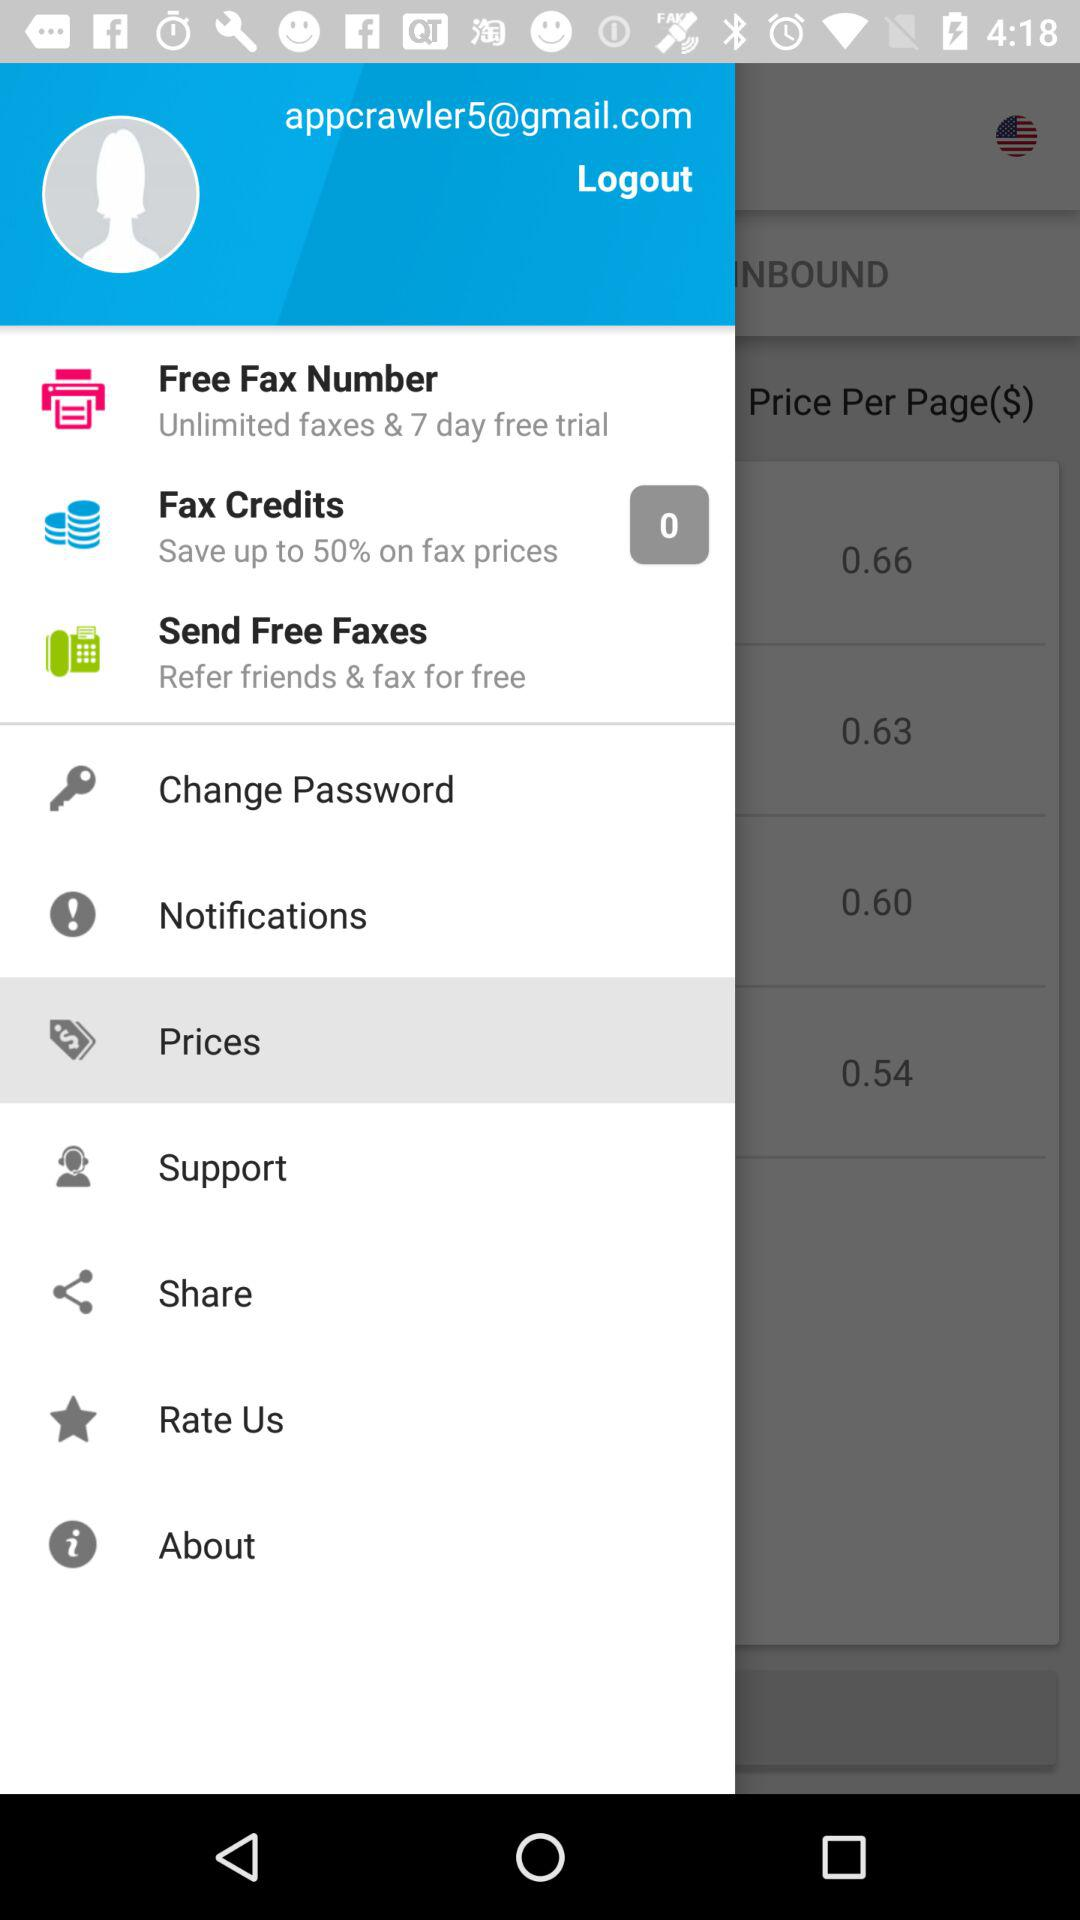For how many days will we get the free trial? You will get the free trial for 7 days. 